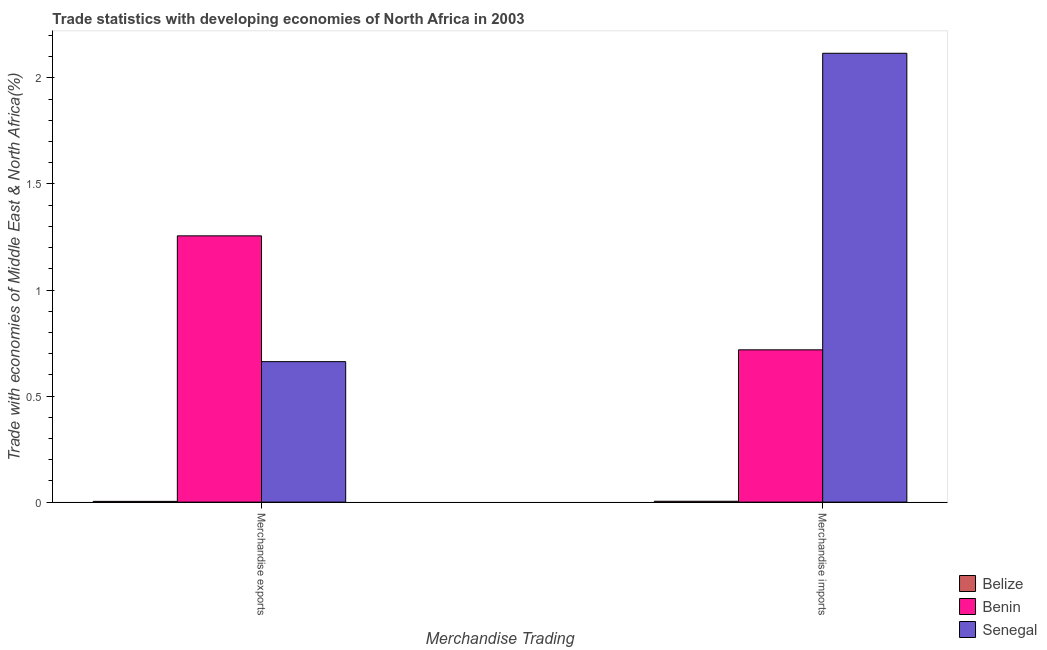How many different coloured bars are there?
Offer a terse response. 3. How many groups of bars are there?
Your answer should be compact. 2. Are the number of bars per tick equal to the number of legend labels?
Offer a very short reply. Yes. Are the number of bars on each tick of the X-axis equal?
Provide a short and direct response. Yes. What is the label of the 2nd group of bars from the left?
Make the answer very short. Merchandise imports. What is the merchandise imports in Benin?
Offer a terse response. 0.72. Across all countries, what is the maximum merchandise imports?
Give a very brief answer. 2.12. Across all countries, what is the minimum merchandise imports?
Your answer should be very brief. 0. In which country was the merchandise exports maximum?
Offer a terse response. Benin. In which country was the merchandise exports minimum?
Offer a very short reply. Belize. What is the total merchandise imports in the graph?
Your answer should be compact. 2.84. What is the difference between the merchandise imports in Benin and that in Senegal?
Make the answer very short. -1.4. What is the difference between the merchandise imports in Benin and the merchandise exports in Senegal?
Provide a succinct answer. 0.06. What is the average merchandise imports per country?
Your answer should be compact. 0.95. What is the difference between the merchandise imports and merchandise exports in Benin?
Offer a very short reply. -0.54. In how many countries, is the merchandise imports greater than 1.2 %?
Provide a succinct answer. 1. What is the ratio of the merchandise exports in Benin to that in Senegal?
Keep it short and to the point. 1.9. Is the merchandise imports in Benin less than that in Belize?
Give a very brief answer. No. In how many countries, is the merchandise imports greater than the average merchandise imports taken over all countries?
Your answer should be very brief. 1. What does the 3rd bar from the left in Merchandise imports represents?
Ensure brevity in your answer.  Senegal. What does the 2nd bar from the right in Merchandise imports represents?
Provide a short and direct response. Benin. Are all the bars in the graph horizontal?
Keep it short and to the point. No. What is the difference between two consecutive major ticks on the Y-axis?
Provide a succinct answer. 0.5. Does the graph contain any zero values?
Keep it short and to the point. No. Does the graph contain grids?
Offer a very short reply. No. How many legend labels are there?
Offer a terse response. 3. What is the title of the graph?
Your response must be concise. Trade statistics with developing economies of North Africa in 2003. Does "Isle of Man" appear as one of the legend labels in the graph?
Offer a very short reply. No. What is the label or title of the X-axis?
Keep it short and to the point. Merchandise Trading. What is the label or title of the Y-axis?
Ensure brevity in your answer.  Trade with economies of Middle East & North Africa(%). What is the Trade with economies of Middle East & North Africa(%) of Belize in Merchandise exports?
Provide a short and direct response. 0. What is the Trade with economies of Middle East & North Africa(%) of Benin in Merchandise exports?
Provide a succinct answer. 1.26. What is the Trade with economies of Middle East & North Africa(%) of Senegal in Merchandise exports?
Your response must be concise. 0.66. What is the Trade with economies of Middle East & North Africa(%) of Belize in Merchandise imports?
Your answer should be compact. 0. What is the Trade with economies of Middle East & North Africa(%) of Benin in Merchandise imports?
Offer a very short reply. 0.72. What is the Trade with economies of Middle East & North Africa(%) of Senegal in Merchandise imports?
Ensure brevity in your answer.  2.12. Across all Merchandise Trading, what is the maximum Trade with economies of Middle East & North Africa(%) of Belize?
Keep it short and to the point. 0. Across all Merchandise Trading, what is the maximum Trade with economies of Middle East & North Africa(%) in Benin?
Offer a very short reply. 1.26. Across all Merchandise Trading, what is the maximum Trade with economies of Middle East & North Africa(%) in Senegal?
Keep it short and to the point. 2.12. Across all Merchandise Trading, what is the minimum Trade with economies of Middle East & North Africa(%) in Belize?
Offer a very short reply. 0. Across all Merchandise Trading, what is the minimum Trade with economies of Middle East & North Africa(%) in Benin?
Make the answer very short. 0.72. Across all Merchandise Trading, what is the minimum Trade with economies of Middle East & North Africa(%) of Senegal?
Your response must be concise. 0.66. What is the total Trade with economies of Middle East & North Africa(%) in Belize in the graph?
Your answer should be very brief. 0.01. What is the total Trade with economies of Middle East & North Africa(%) of Benin in the graph?
Your response must be concise. 1.97. What is the total Trade with economies of Middle East & North Africa(%) in Senegal in the graph?
Your answer should be compact. 2.78. What is the difference between the Trade with economies of Middle East & North Africa(%) in Belize in Merchandise exports and that in Merchandise imports?
Make the answer very short. -0. What is the difference between the Trade with economies of Middle East & North Africa(%) of Benin in Merchandise exports and that in Merchandise imports?
Your answer should be compact. 0.54. What is the difference between the Trade with economies of Middle East & North Africa(%) of Senegal in Merchandise exports and that in Merchandise imports?
Make the answer very short. -1.45. What is the difference between the Trade with economies of Middle East & North Africa(%) of Belize in Merchandise exports and the Trade with economies of Middle East & North Africa(%) of Benin in Merchandise imports?
Your response must be concise. -0.71. What is the difference between the Trade with economies of Middle East & North Africa(%) in Belize in Merchandise exports and the Trade with economies of Middle East & North Africa(%) in Senegal in Merchandise imports?
Ensure brevity in your answer.  -2.11. What is the difference between the Trade with economies of Middle East & North Africa(%) in Benin in Merchandise exports and the Trade with economies of Middle East & North Africa(%) in Senegal in Merchandise imports?
Make the answer very short. -0.86. What is the average Trade with economies of Middle East & North Africa(%) of Belize per Merchandise Trading?
Make the answer very short. 0. What is the average Trade with economies of Middle East & North Africa(%) of Senegal per Merchandise Trading?
Provide a succinct answer. 1.39. What is the difference between the Trade with economies of Middle East & North Africa(%) of Belize and Trade with economies of Middle East & North Africa(%) of Benin in Merchandise exports?
Your answer should be very brief. -1.25. What is the difference between the Trade with economies of Middle East & North Africa(%) in Belize and Trade with economies of Middle East & North Africa(%) in Senegal in Merchandise exports?
Your answer should be very brief. -0.66. What is the difference between the Trade with economies of Middle East & North Africa(%) of Benin and Trade with economies of Middle East & North Africa(%) of Senegal in Merchandise exports?
Keep it short and to the point. 0.59. What is the difference between the Trade with economies of Middle East & North Africa(%) of Belize and Trade with economies of Middle East & North Africa(%) of Benin in Merchandise imports?
Give a very brief answer. -0.71. What is the difference between the Trade with economies of Middle East & North Africa(%) in Belize and Trade with economies of Middle East & North Africa(%) in Senegal in Merchandise imports?
Keep it short and to the point. -2.11. What is the difference between the Trade with economies of Middle East & North Africa(%) in Benin and Trade with economies of Middle East & North Africa(%) in Senegal in Merchandise imports?
Keep it short and to the point. -1.4. What is the ratio of the Trade with economies of Middle East & North Africa(%) in Belize in Merchandise exports to that in Merchandise imports?
Give a very brief answer. 0.86. What is the ratio of the Trade with economies of Middle East & North Africa(%) in Benin in Merchandise exports to that in Merchandise imports?
Offer a terse response. 1.75. What is the ratio of the Trade with economies of Middle East & North Africa(%) of Senegal in Merchandise exports to that in Merchandise imports?
Provide a short and direct response. 0.31. What is the difference between the highest and the second highest Trade with economies of Middle East & North Africa(%) of Belize?
Provide a succinct answer. 0. What is the difference between the highest and the second highest Trade with economies of Middle East & North Africa(%) of Benin?
Provide a succinct answer. 0.54. What is the difference between the highest and the second highest Trade with economies of Middle East & North Africa(%) in Senegal?
Offer a very short reply. 1.45. What is the difference between the highest and the lowest Trade with economies of Middle East & North Africa(%) in Belize?
Provide a succinct answer. 0. What is the difference between the highest and the lowest Trade with economies of Middle East & North Africa(%) in Benin?
Offer a very short reply. 0.54. What is the difference between the highest and the lowest Trade with economies of Middle East & North Africa(%) of Senegal?
Ensure brevity in your answer.  1.45. 